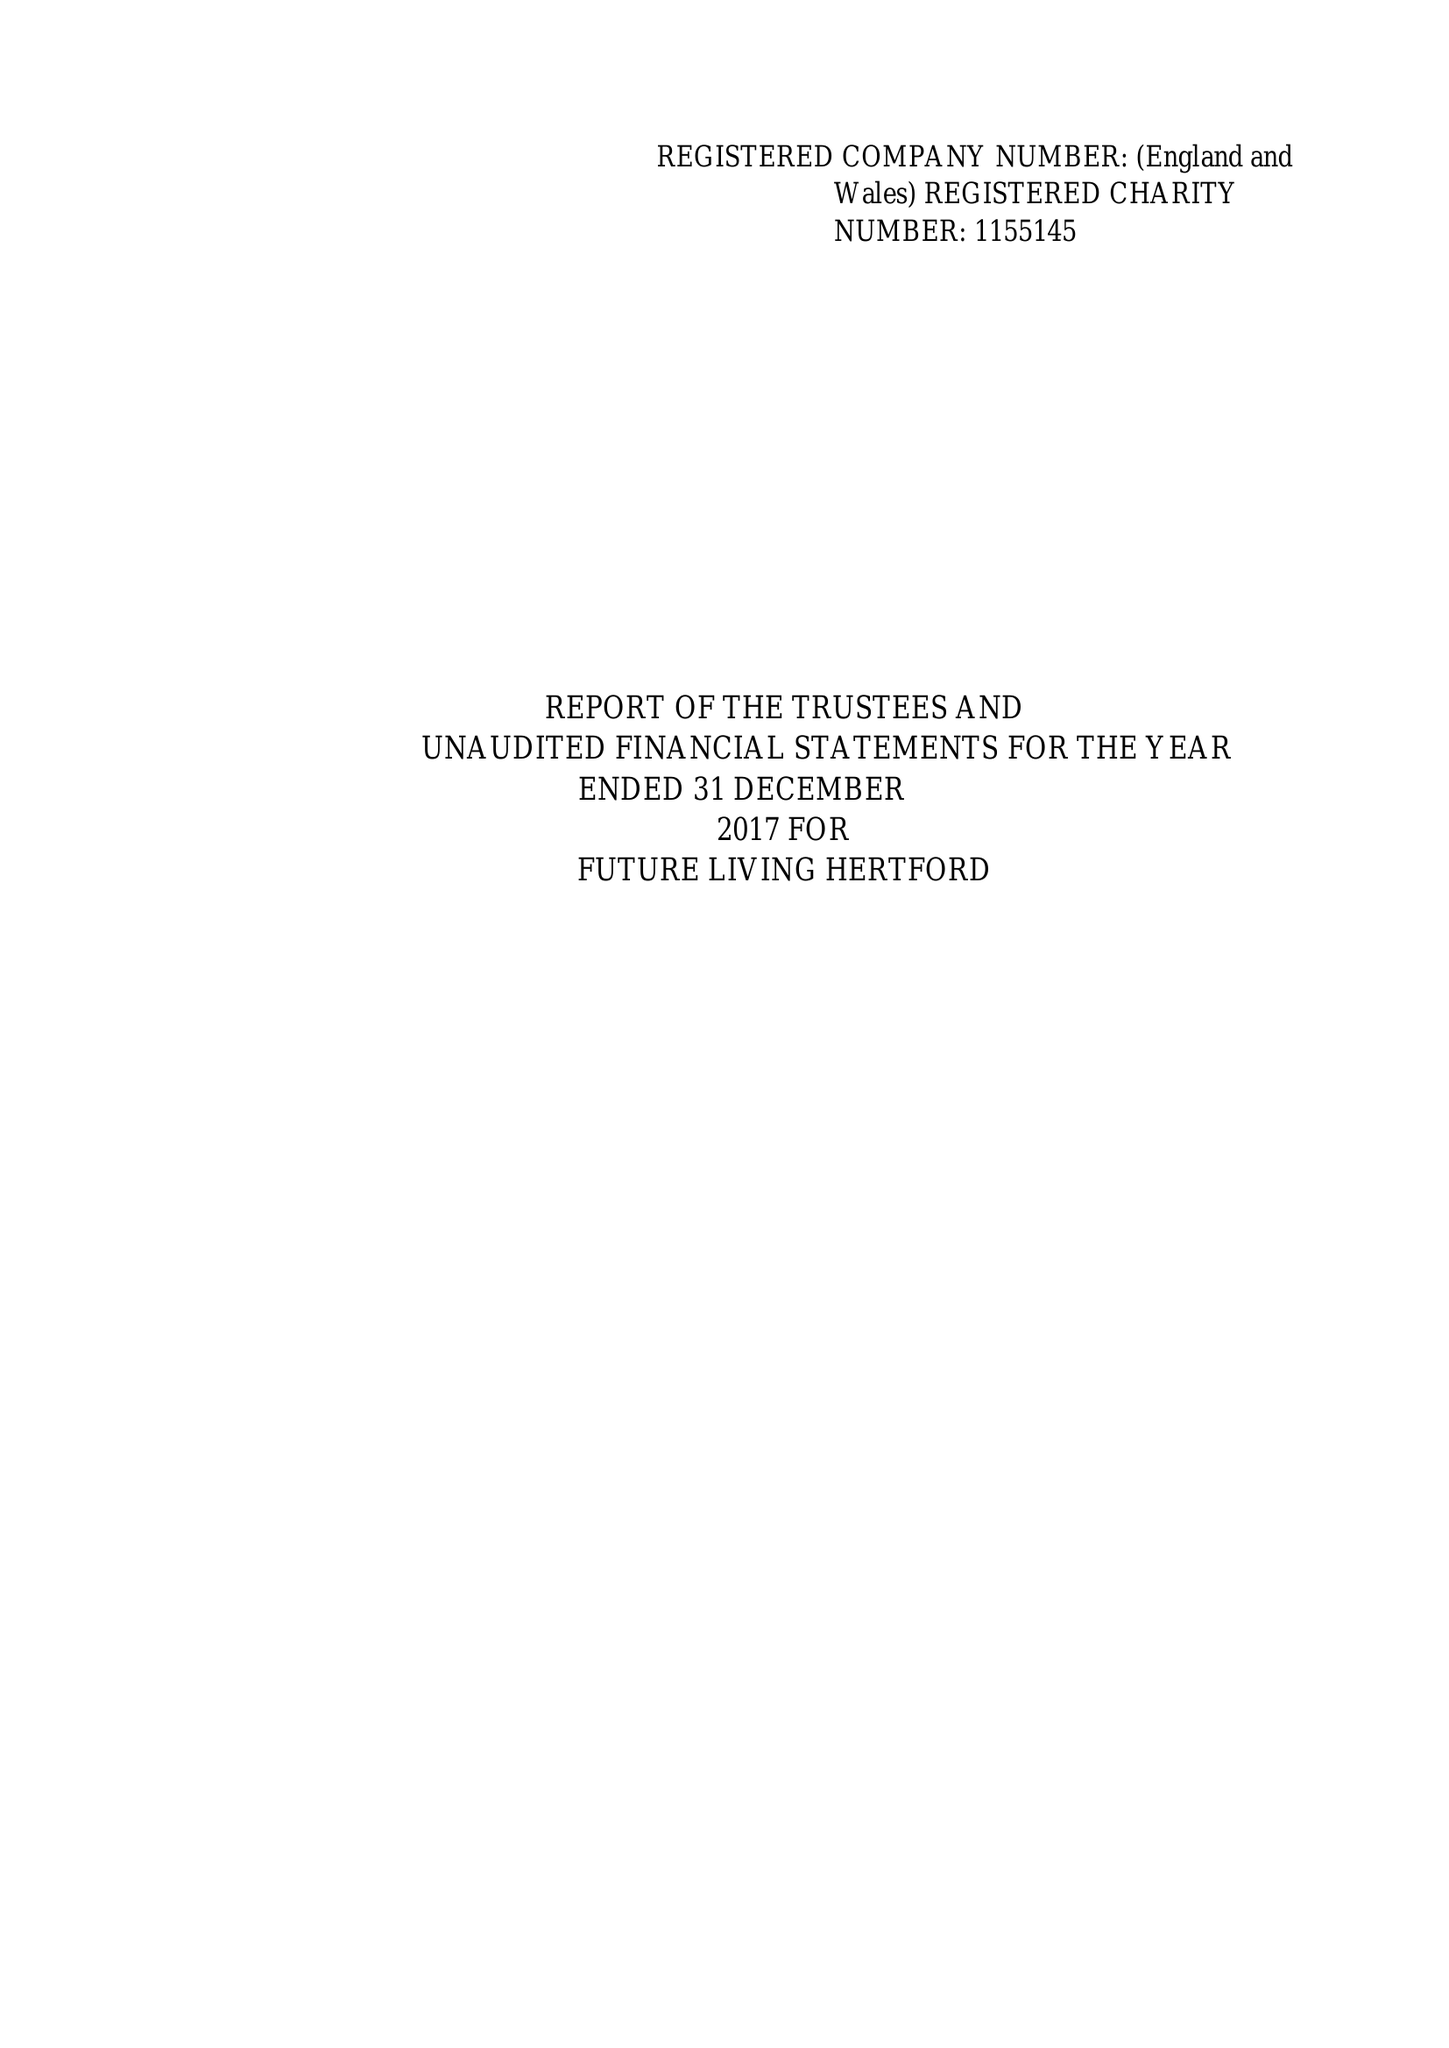What is the value for the income_annually_in_british_pounds?
Answer the question using a single word or phrase. 107606.00 